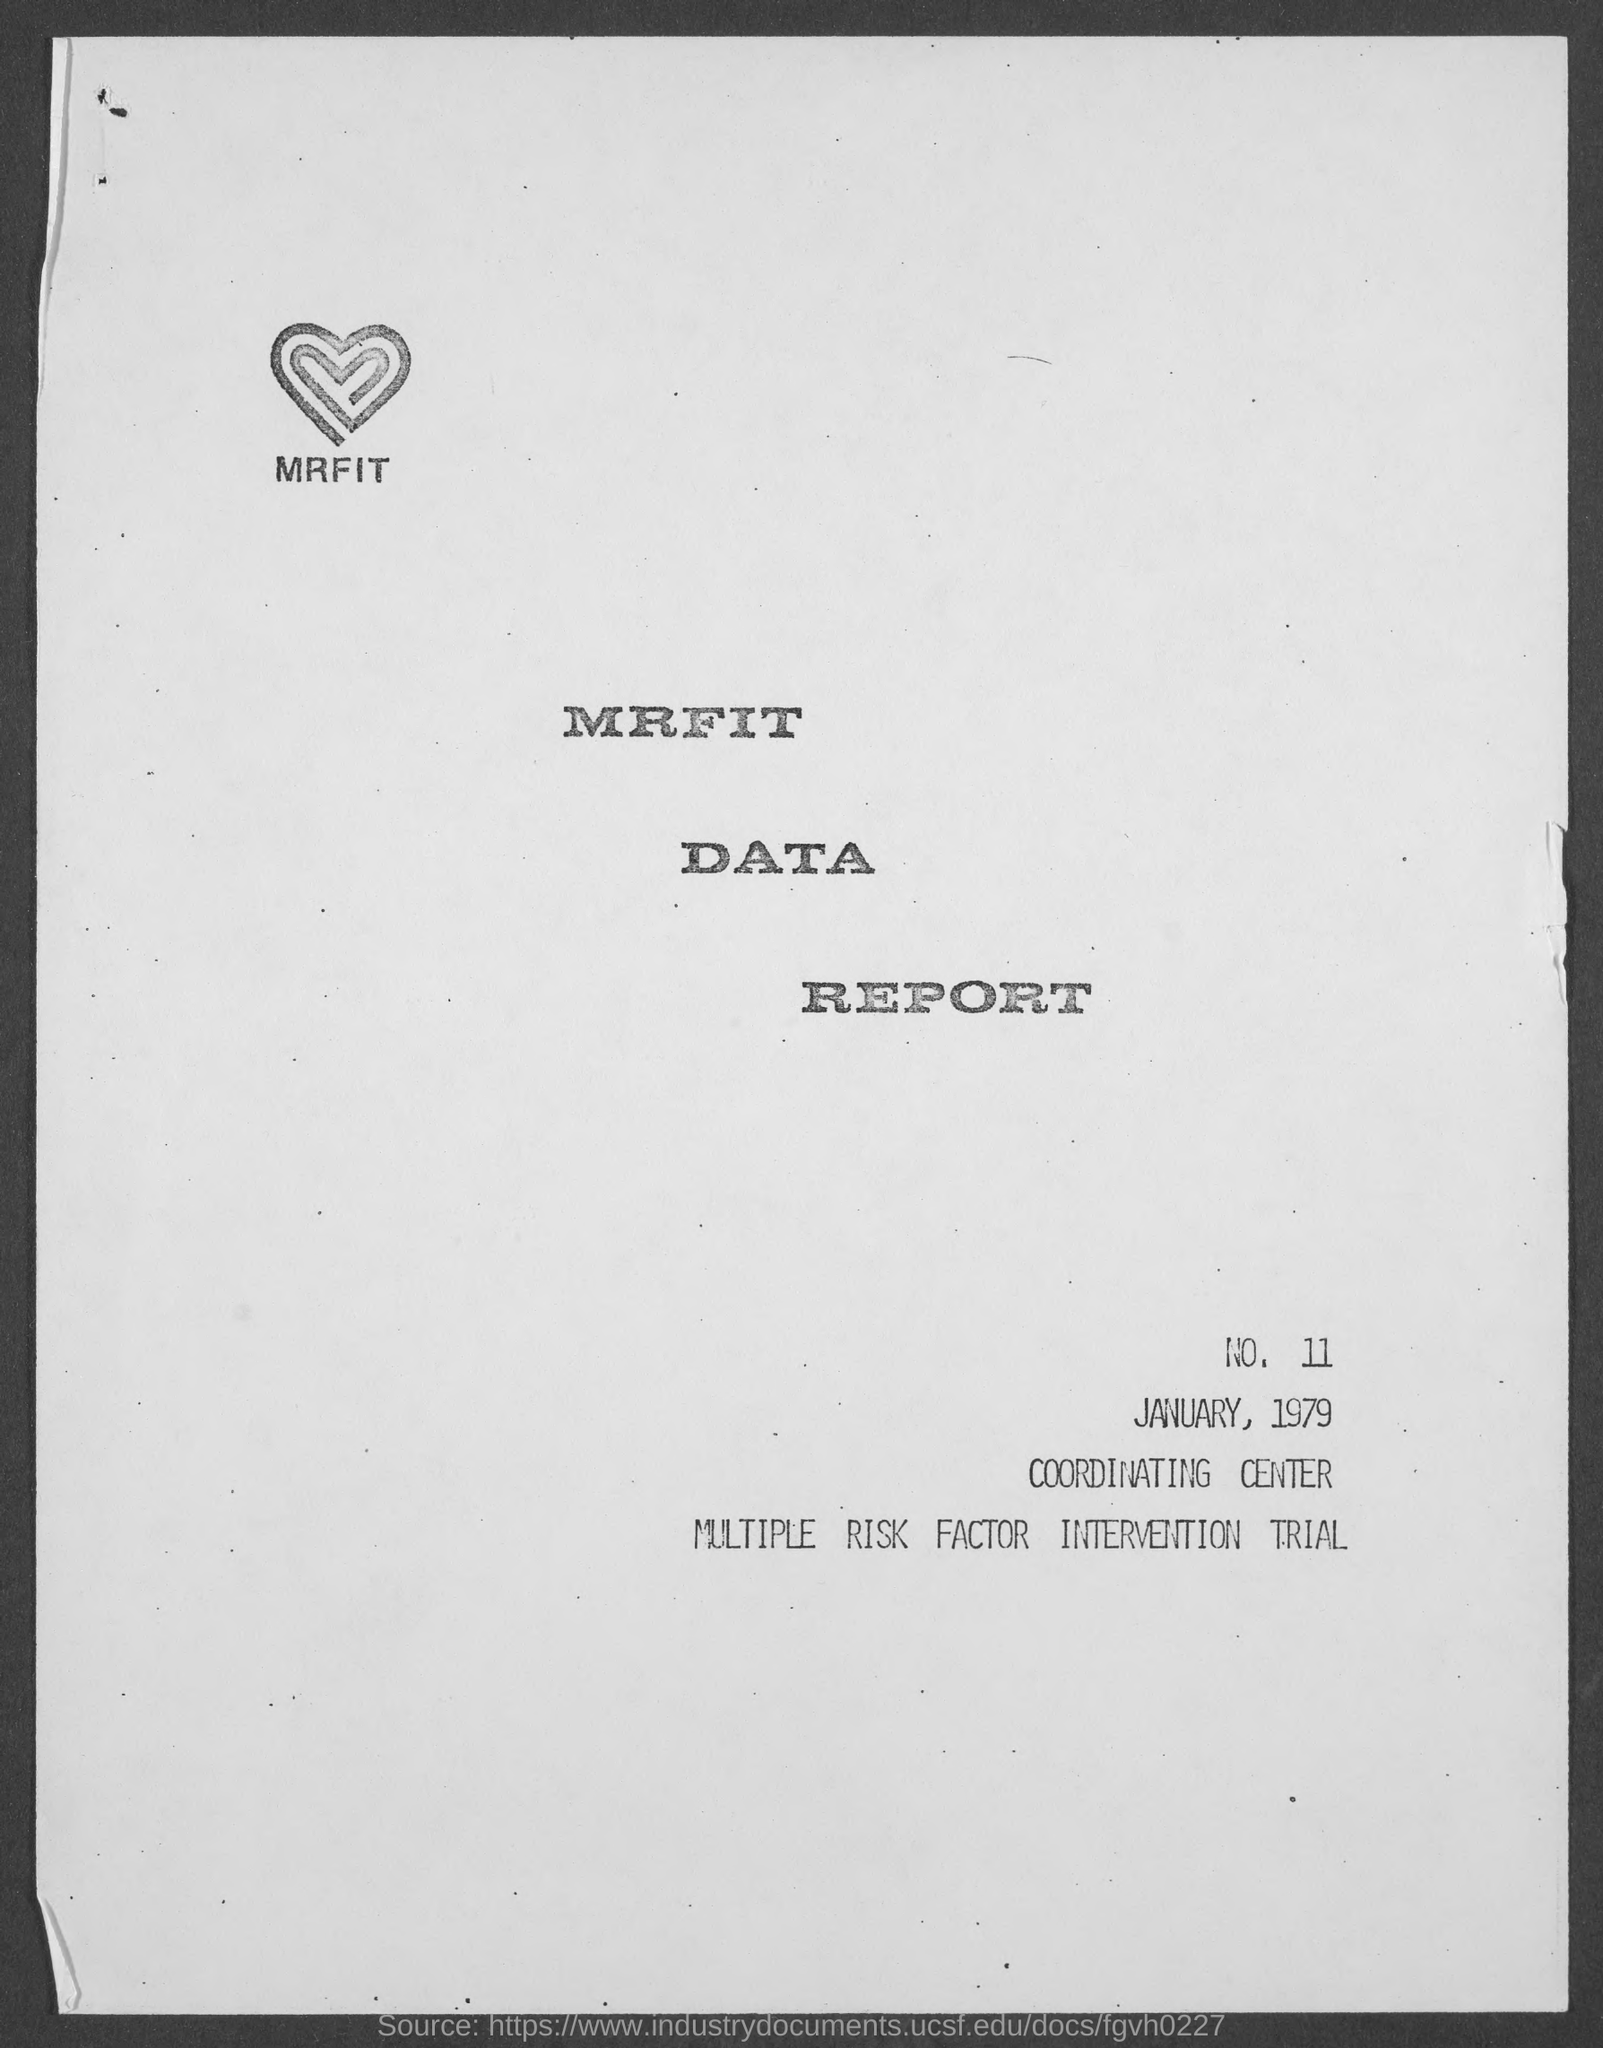What does MRFIT stands?
Offer a terse response. MULTIPLE RISK FACTOR INTERVENTION TRIAL. What is the date mentioned in the report?
Your answer should be compact. JANUARY, 1979. 